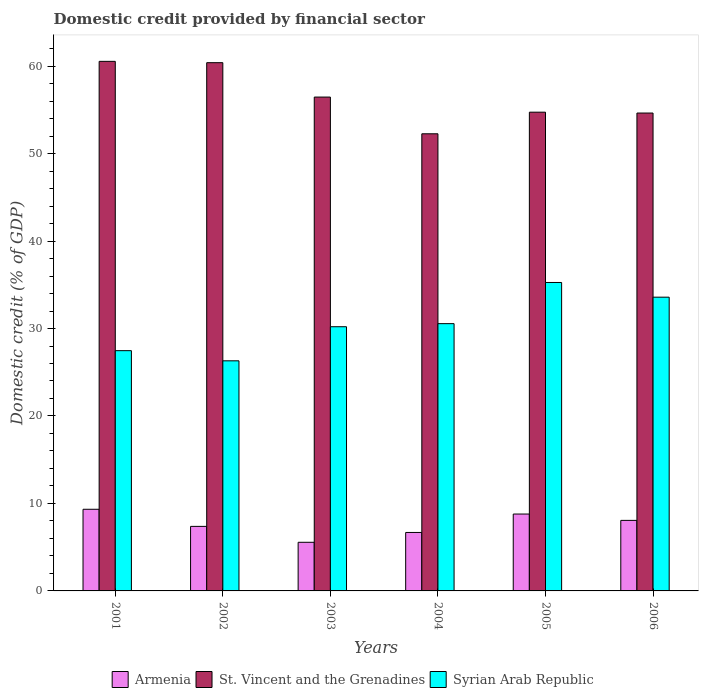Are the number of bars per tick equal to the number of legend labels?
Provide a succinct answer. Yes. How many bars are there on the 6th tick from the right?
Your answer should be very brief. 3. In how many cases, is the number of bars for a given year not equal to the number of legend labels?
Make the answer very short. 0. What is the domestic credit in Syrian Arab Republic in 2003?
Give a very brief answer. 30.2. Across all years, what is the maximum domestic credit in Armenia?
Provide a short and direct response. 9.33. Across all years, what is the minimum domestic credit in St. Vincent and the Grenadines?
Your answer should be compact. 52.26. In which year was the domestic credit in St. Vincent and the Grenadines minimum?
Offer a terse response. 2004. What is the total domestic credit in Syrian Arab Republic in the graph?
Ensure brevity in your answer.  183.38. What is the difference between the domestic credit in Syrian Arab Republic in 2004 and that in 2006?
Your answer should be very brief. -3.03. What is the difference between the domestic credit in Armenia in 2006 and the domestic credit in St. Vincent and the Grenadines in 2004?
Keep it short and to the point. -44.2. What is the average domestic credit in St. Vincent and the Grenadines per year?
Offer a terse response. 56.5. In the year 2003, what is the difference between the domestic credit in St. Vincent and the Grenadines and domestic credit in Armenia?
Give a very brief answer. 50.9. In how many years, is the domestic credit in Armenia greater than 32 %?
Your response must be concise. 0. What is the ratio of the domestic credit in Armenia in 2003 to that in 2005?
Keep it short and to the point. 0.63. Is the domestic credit in St. Vincent and the Grenadines in 2004 less than that in 2005?
Make the answer very short. Yes. Is the difference between the domestic credit in St. Vincent and the Grenadines in 2002 and 2003 greater than the difference between the domestic credit in Armenia in 2002 and 2003?
Your answer should be very brief. Yes. What is the difference between the highest and the second highest domestic credit in Syrian Arab Republic?
Provide a succinct answer. 1.68. What is the difference between the highest and the lowest domestic credit in St. Vincent and the Grenadines?
Make the answer very short. 8.28. What does the 3rd bar from the left in 2003 represents?
Your response must be concise. Syrian Arab Republic. What does the 2nd bar from the right in 2002 represents?
Offer a terse response. St. Vincent and the Grenadines. Are all the bars in the graph horizontal?
Your response must be concise. No. How many years are there in the graph?
Provide a short and direct response. 6. Are the values on the major ticks of Y-axis written in scientific E-notation?
Provide a succinct answer. No. Does the graph contain grids?
Offer a very short reply. No. Where does the legend appear in the graph?
Provide a short and direct response. Bottom center. How are the legend labels stacked?
Your answer should be very brief. Horizontal. What is the title of the graph?
Offer a terse response. Domestic credit provided by financial sector. What is the label or title of the Y-axis?
Offer a very short reply. Domestic credit (% of GDP). What is the Domestic credit (% of GDP) of Armenia in 2001?
Your response must be concise. 9.33. What is the Domestic credit (% of GDP) of St. Vincent and the Grenadines in 2001?
Provide a succinct answer. 60.54. What is the Domestic credit (% of GDP) of Syrian Arab Republic in 2001?
Keep it short and to the point. 27.47. What is the Domestic credit (% of GDP) in Armenia in 2002?
Provide a succinct answer. 7.38. What is the Domestic credit (% of GDP) of St. Vincent and the Grenadines in 2002?
Your answer should be very brief. 60.39. What is the Domestic credit (% of GDP) in Syrian Arab Republic in 2002?
Offer a terse response. 26.31. What is the Domestic credit (% of GDP) of Armenia in 2003?
Offer a very short reply. 5.56. What is the Domestic credit (% of GDP) in St. Vincent and the Grenadines in 2003?
Provide a succinct answer. 56.46. What is the Domestic credit (% of GDP) of Syrian Arab Republic in 2003?
Offer a very short reply. 30.2. What is the Domestic credit (% of GDP) of Armenia in 2004?
Your response must be concise. 6.68. What is the Domestic credit (% of GDP) in St. Vincent and the Grenadines in 2004?
Provide a succinct answer. 52.26. What is the Domestic credit (% of GDP) in Syrian Arab Republic in 2004?
Your answer should be very brief. 30.55. What is the Domestic credit (% of GDP) of Armenia in 2005?
Ensure brevity in your answer.  8.79. What is the Domestic credit (% of GDP) in St. Vincent and the Grenadines in 2005?
Give a very brief answer. 54.73. What is the Domestic credit (% of GDP) of Syrian Arab Republic in 2005?
Ensure brevity in your answer.  35.26. What is the Domestic credit (% of GDP) in Armenia in 2006?
Offer a very short reply. 8.06. What is the Domestic credit (% of GDP) of St. Vincent and the Grenadines in 2006?
Make the answer very short. 54.63. What is the Domestic credit (% of GDP) in Syrian Arab Republic in 2006?
Offer a terse response. 33.58. Across all years, what is the maximum Domestic credit (% of GDP) in Armenia?
Ensure brevity in your answer.  9.33. Across all years, what is the maximum Domestic credit (% of GDP) of St. Vincent and the Grenadines?
Keep it short and to the point. 60.54. Across all years, what is the maximum Domestic credit (% of GDP) in Syrian Arab Republic?
Your answer should be very brief. 35.26. Across all years, what is the minimum Domestic credit (% of GDP) in Armenia?
Your answer should be very brief. 5.56. Across all years, what is the minimum Domestic credit (% of GDP) in St. Vincent and the Grenadines?
Ensure brevity in your answer.  52.26. Across all years, what is the minimum Domestic credit (% of GDP) in Syrian Arab Republic?
Your response must be concise. 26.31. What is the total Domestic credit (% of GDP) in Armenia in the graph?
Give a very brief answer. 45.81. What is the total Domestic credit (% of GDP) in St. Vincent and the Grenadines in the graph?
Your answer should be compact. 339.02. What is the total Domestic credit (% of GDP) of Syrian Arab Republic in the graph?
Your answer should be very brief. 183.38. What is the difference between the Domestic credit (% of GDP) in Armenia in 2001 and that in 2002?
Provide a short and direct response. 1.96. What is the difference between the Domestic credit (% of GDP) of St. Vincent and the Grenadines in 2001 and that in 2002?
Offer a very short reply. 0.15. What is the difference between the Domestic credit (% of GDP) in Syrian Arab Republic in 2001 and that in 2002?
Provide a short and direct response. 1.16. What is the difference between the Domestic credit (% of GDP) of Armenia in 2001 and that in 2003?
Give a very brief answer. 3.78. What is the difference between the Domestic credit (% of GDP) in St. Vincent and the Grenadines in 2001 and that in 2003?
Provide a short and direct response. 4.08. What is the difference between the Domestic credit (% of GDP) of Syrian Arab Republic in 2001 and that in 2003?
Your answer should be compact. -2.74. What is the difference between the Domestic credit (% of GDP) of Armenia in 2001 and that in 2004?
Offer a terse response. 2.65. What is the difference between the Domestic credit (% of GDP) of St. Vincent and the Grenadines in 2001 and that in 2004?
Ensure brevity in your answer.  8.28. What is the difference between the Domestic credit (% of GDP) in Syrian Arab Republic in 2001 and that in 2004?
Keep it short and to the point. -3.09. What is the difference between the Domestic credit (% of GDP) in Armenia in 2001 and that in 2005?
Keep it short and to the point. 0.55. What is the difference between the Domestic credit (% of GDP) in St. Vincent and the Grenadines in 2001 and that in 2005?
Your answer should be compact. 5.81. What is the difference between the Domestic credit (% of GDP) in Syrian Arab Republic in 2001 and that in 2005?
Ensure brevity in your answer.  -7.8. What is the difference between the Domestic credit (% of GDP) of Armenia in 2001 and that in 2006?
Your response must be concise. 1.27. What is the difference between the Domestic credit (% of GDP) of St. Vincent and the Grenadines in 2001 and that in 2006?
Provide a short and direct response. 5.91. What is the difference between the Domestic credit (% of GDP) in Syrian Arab Republic in 2001 and that in 2006?
Your answer should be compact. -6.12. What is the difference between the Domestic credit (% of GDP) of Armenia in 2002 and that in 2003?
Give a very brief answer. 1.82. What is the difference between the Domestic credit (% of GDP) of St. Vincent and the Grenadines in 2002 and that in 2003?
Your answer should be compact. 3.93. What is the difference between the Domestic credit (% of GDP) of Syrian Arab Republic in 2002 and that in 2003?
Your answer should be very brief. -3.9. What is the difference between the Domestic credit (% of GDP) in Armenia in 2002 and that in 2004?
Ensure brevity in your answer.  0.69. What is the difference between the Domestic credit (% of GDP) of St. Vincent and the Grenadines in 2002 and that in 2004?
Your answer should be compact. 8.13. What is the difference between the Domestic credit (% of GDP) of Syrian Arab Republic in 2002 and that in 2004?
Your answer should be very brief. -4.25. What is the difference between the Domestic credit (% of GDP) of Armenia in 2002 and that in 2005?
Give a very brief answer. -1.41. What is the difference between the Domestic credit (% of GDP) in St. Vincent and the Grenadines in 2002 and that in 2005?
Keep it short and to the point. 5.66. What is the difference between the Domestic credit (% of GDP) in Syrian Arab Republic in 2002 and that in 2005?
Give a very brief answer. -8.96. What is the difference between the Domestic credit (% of GDP) in Armenia in 2002 and that in 2006?
Your response must be concise. -0.69. What is the difference between the Domestic credit (% of GDP) in St. Vincent and the Grenadines in 2002 and that in 2006?
Offer a very short reply. 5.76. What is the difference between the Domestic credit (% of GDP) in Syrian Arab Republic in 2002 and that in 2006?
Provide a short and direct response. -7.28. What is the difference between the Domestic credit (% of GDP) of Armenia in 2003 and that in 2004?
Offer a terse response. -1.12. What is the difference between the Domestic credit (% of GDP) in St. Vincent and the Grenadines in 2003 and that in 2004?
Your answer should be very brief. 4.2. What is the difference between the Domestic credit (% of GDP) of Syrian Arab Republic in 2003 and that in 2004?
Keep it short and to the point. -0.35. What is the difference between the Domestic credit (% of GDP) of Armenia in 2003 and that in 2005?
Your response must be concise. -3.23. What is the difference between the Domestic credit (% of GDP) of St. Vincent and the Grenadines in 2003 and that in 2005?
Your answer should be very brief. 1.73. What is the difference between the Domestic credit (% of GDP) of Syrian Arab Republic in 2003 and that in 2005?
Provide a short and direct response. -5.06. What is the difference between the Domestic credit (% of GDP) of Armenia in 2003 and that in 2006?
Your answer should be compact. -2.5. What is the difference between the Domestic credit (% of GDP) in St. Vincent and the Grenadines in 2003 and that in 2006?
Offer a very short reply. 1.83. What is the difference between the Domestic credit (% of GDP) in Syrian Arab Republic in 2003 and that in 2006?
Make the answer very short. -3.38. What is the difference between the Domestic credit (% of GDP) of Armenia in 2004 and that in 2005?
Your answer should be very brief. -2.1. What is the difference between the Domestic credit (% of GDP) in St. Vincent and the Grenadines in 2004 and that in 2005?
Your answer should be compact. -2.47. What is the difference between the Domestic credit (% of GDP) of Syrian Arab Republic in 2004 and that in 2005?
Make the answer very short. -4.71. What is the difference between the Domestic credit (% of GDP) of Armenia in 2004 and that in 2006?
Your answer should be compact. -1.38. What is the difference between the Domestic credit (% of GDP) of St. Vincent and the Grenadines in 2004 and that in 2006?
Your response must be concise. -2.37. What is the difference between the Domestic credit (% of GDP) of Syrian Arab Republic in 2004 and that in 2006?
Provide a short and direct response. -3.03. What is the difference between the Domestic credit (% of GDP) in Armenia in 2005 and that in 2006?
Give a very brief answer. 0.72. What is the difference between the Domestic credit (% of GDP) of St. Vincent and the Grenadines in 2005 and that in 2006?
Your response must be concise. 0.1. What is the difference between the Domestic credit (% of GDP) in Syrian Arab Republic in 2005 and that in 2006?
Offer a very short reply. 1.68. What is the difference between the Domestic credit (% of GDP) in Armenia in 2001 and the Domestic credit (% of GDP) in St. Vincent and the Grenadines in 2002?
Provide a short and direct response. -51.06. What is the difference between the Domestic credit (% of GDP) of Armenia in 2001 and the Domestic credit (% of GDP) of Syrian Arab Republic in 2002?
Keep it short and to the point. -16.97. What is the difference between the Domestic credit (% of GDP) in St. Vincent and the Grenadines in 2001 and the Domestic credit (% of GDP) in Syrian Arab Republic in 2002?
Give a very brief answer. 34.24. What is the difference between the Domestic credit (% of GDP) in Armenia in 2001 and the Domestic credit (% of GDP) in St. Vincent and the Grenadines in 2003?
Your answer should be compact. -47.12. What is the difference between the Domestic credit (% of GDP) of Armenia in 2001 and the Domestic credit (% of GDP) of Syrian Arab Republic in 2003?
Offer a terse response. -20.87. What is the difference between the Domestic credit (% of GDP) of St. Vincent and the Grenadines in 2001 and the Domestic credit (% of GDP) of Syrian Arab Republic in 2003?
Your answer should be compact. 30.34. What is the difference between the Domestic credit (% of GDP) of Armenia in 2001 and the Domestic credit (% of GDP) of St. Vincent and the Grenadines in 2004?
Ensure brevity in your answer.  -42.93. What is the difference between the Domestic credit (% of GDP) in Armenia in 2001 and the Domestic credit (% of GDP) in Syrian Arab Republic in 2004?
Provide a short and direct response. -21.22. What is the difference between the Domestic credit (% of GDP) of St. Vincent and the Grenadines in 2001 and the Domestic credit (% of GDP) of Syrian Arab Republic in 2004?
Provide a succinct answer. 29.99. What is the difference between the Domestic credit (% of GDP) in Armenia in 2001 and the Domestic credit (% of GDP) in St. Vincent and the Grenadines in 2005?
Keep it short and to the point. -45.4. What is the difference between the Domestic credit (% of GDP) of Armenia in 2001 and the Domestic credit (% of GDP) of Syrian Arab Republic in 2005?
Give a very brief answer. -25.93. What is the difference between the Domestic credit (% of GDP) in St. Vincent and the Grenadines in 2001 and the Domestic credit (% of GDP) in Syrian Arab Republic in 2005?
Provide a short and direct response. 25.28. What is the difference between the Domestic credit (% of GDP) of Armenia in 2001 and the Domestic credit (% of GDP) of St. Vincent and the Grenadines in 2006?
Your answer should be compact. -45.3. What is the difference between the Domestic credit (% of GDP) of Armenia in 2001 and the Domestic credit (% of GDP) of Syrian Arab Republic in 2006?
Provide a succinct answer. -24.25. What is the difference between the Domestic credit (% of GDP) in St. Vincent and the Grenadines in 2001 and the Domestic credit (% of GDP) in Syrian Arab Republic in 2006?
Ensure brevity in your answer.  26.96. What is the difference between the Domestic credit (% of GDP) of Armenia in 2002 and the Domestic credit (% of GDP) of St. Vincent and the Grenadines in 2003?
Your response must be concise. -49.08. What is the difference between the Domestic credit (% of GDP) in Armenia in 2002 and the Domestic credit (% of GDP) in Syrian Arab Republic in 2003?
Make the answer very short. -22.82. What is the difference between the Domestic credit (% of GDP) in St. Vincent and the Grenadines in 2002 and the Domestic credit (% of GDP) in Syrian Arab Republic in 2003?
Your answer should be very brief. 30.19. What is the difference between the Domestic credit (% of GDP) in Armenia in 2002 and the Domestic credit (% of GDP) in St. Vincent and the Grenadines in 2004?
Your response must be concise. -44.88. What is the difference between the Domestic credit (% of GDP) in Armenia in 2002 and the Domestic credit (% of GDP) in Syrian Arab Republic in 2004?
Your response must be concise. -23.18. What is the difference between the Domestic credit (% of GDP) in St. Vincent and the Grenadines in 2002 and the Domestic credit (% of GDP) in Syrian Arab Republic in 2004?
Offer a terse response. 29.84. What is the difference between the Domestic credit (% of GDP) of Armenia in 2002 and the Domestic credit (% of GDP) of St. Vincent and the Grenadines in 2005?
Make the answer very short. -47.35. What is the difference between the Domestic credit (% of GDP) of Armenia in 2002 and the Domestic credit (% of GDP) of Syrian Arab Republic in 2005?
Keep it short and to the point. -27.88. What is the difference between the Domestic credit (% of GDP) in St. Vincent and the Grenadines in 2002 and the Domestic credit (% of GDP) in Syrian Arab Republic in 2005?
Provide a succinct answer. 25.13. What is the difference between the Domestic credit (% of GDP) in Armenia in 2002 and the Domestic credit (% of GDP) in St. Vincent and the Grenadines in 2006?
Give a very brief answer. -47.25. What is the difference between the Domestic credit (% of GDP) of Armenia in 2002 and the Domestic credit (% of GDP) of Syrian Arab Republic in 2006?
Your answer should be compact. -26.2. What is the difference between the Domestic credit (% of GDP) in St. Vincent and the Grenadines in 2002 and the Domestic credit (% of GDP) in Syrian Arab Republic in 2006?
Your answer should be compact. 26.81. What is the difference between the Domestic credit (% of GDP) in Armenia in 2003 and the Domestic credit (% of GDP) in St. Vincent and the Grenadines in 2004?
Offer a terse response. -46.7. What is the difference between the Domestic credit (% of GDP) of Armenia in 2003 and the Domestic credit (% of GDP) of Syrian Arab Republic in 2004?
Offer a very short reply. -25. What is the difference between the Domestic credit (% of GDP) in St. Vincent and the Grenadines in 2003 and the Domestic credit (% of GDP) in Syrian Arab Republic in 2004?
Provide a succinct answer. 25.9. What is the difference between the Domestic credit (% of GDP) in Armenia in 2003 and the Domestic credit (% of GDP) in St. Vincent and the Grenadines in 2005?
Ensure brevity in your answer.  -49.17. What is the difference between the Domestic credit (% of GDP) of Armenia in 2003 and the Domestic credit (% of GDP) of Syrian Arab Republic in 2005?
Offer a very short reply. -29.7. What is the difference between the Domestic credit (% of GDP) of St. Vincent and the Grenadines in 2003 and the Domestic credit (% of GDP) of Syrian Arab Republic in 2005?
Ensure brevity in your answer.  21.2. What is the difference between the Domestic credit (% of GDP) in Armenia in 2003 and the Domestic credit (% of GDP) in St. Vincent and the Grenadines in 2006?
Ensure brevity in your answer.  -49.07. What is the difference between the Domestic credit (% of GDP) of Armenia in 2003 and the Domestic credit (% of GDP) of Syrian Arab Republic in 2006?
Your answer should be very brief. -28.02. What is the difference between the Domestic credit (% of GDP) in St. Vincent and the Grenadines in 2003 and the Domestic credit (% of GDP) in Syrian Arab Republic in 2006?
Offer a terse response. 22.88. What is the difference between the Domestic credit (% of GDP) of Armenia in 2004 and the Domestic credit (% of GDP) of St. Vincent and the Grenadines in 2005?
Ensure brevity in your answer.  -48.05. What is the difference between the Domestic credit (% of GDP) in Armenia in 2004 and the Domestic credit (% of GDP) in Syrian Arab Republic in 2005?
Offer a very short reply. -28.58. What is the difference between the Domestic credit (% of GDP) in St. Vincent and the Grenadines in 2004 and the Domestic credit (% of GDP) in Syrian Arab Republic in 2005?
Keep it short and to the point. 17. What is the difference between the Domestic credit (% of GDP) in Armenia in 2004 and the Domestic credit (% of GDP) in St. Vincent and the Grenadines in 2006?
Your answer should be compact. -47.95. What is the difference between the Domestic credit (% of GDP) of Armenia in 2004 and the Domestic credit (% of GDP) of Syrian Arab Republic in 2006?
Offer a terse response. -26.9. What is the difference between the Domestic credit (% of GDP) of St. Vincent and the Grenadines in 2004 and the Domestic credit (% of GDP) of Syrian Arab Republic in 2006?
Your response must be concise. 18.68. What is the difference between the Domestic credit (% of GDP) of Armenia in 2005 and the Domestic credit (% of GDP) of St. Vincent and the Grenadines in 2006?
Offer a terse response. -45.84. What is the difference between the Domestic credit (% of GDP) in Armenia in 2005 and the Domestic credit (% of GDP) in Syrian Arab Republic in 2006?
Offer a terse response. -24.79. What is the difference between the Domestic credit (% of GDP) in St. Vincent and the Grenadines in 2005 and the Domestic credit (% of GDP) in Syrian Arab Republic in 2006?
Your answer should be compact. 21.15. What is the average Domestic credit (% of GDP) of Armenia per year?
Give a very brief answer. 7.63. What is the average Domestic credit (% of GDP) of St. Vincent and the Grenadines per year?
Provide a succinct answer. 56.5. What is the average Domestic credit (% of GDP) in Syrian Arab Republic per year?
Keep it short and to the point. 30.56. In the year 2001, what is the difference between the Domestic credit (% of GDP) in Armenia and Domestic credit (% of GDP) in St. Vincent and the Grenadines?
Give a very brief answer. -51.21. In the year 2001, what is the difference between the Domestic credit (% of GDP) in Armenia and Domestic credit (% of GDP) in Syrian Arab Republic?
Offer a terse response. -18.13. In the year 2001, what is the difference between the Domestic credit (% of GDP) in St. Vincent and the Grenadines and Domestic credit (% of GDP) in Syrian Arab Republic?
Provide a short and direct response. 33.08. In the year 2002, what is the difference between the Domestic credit (% of GDP) in Armenia and Domestic credit (% of GDP) in St. Vincent and the Grenadines?
Ensure brevity in your answer.  -53.01. In the year 2002, what is the difference between the Domestic credit (% of GDP) in Armenia and Domestic credit (% of GDP) in Syrian Arab Republic?
Offer a terse response. -18.93. In the year 2002, what is the difference between the Domestic credit (% of GDP) in St. Vincent and the Grenadines and Domestic credit (% of GDP) in Syrian Arab Republic?
Your answer should be compact. 34.08. In the year 2003, what is the difference between the Domestic credit (% of GDP) in Armenia and Domestic credit (% of GDP) in St. Vincent and the Grenadines?
Provide a short and direct response. -50.9. In the year 2003, what is the difference between the Domestic credit (% of GDP) in Armenia and Domestic credit (% of GDP) in Syrian Arab Republic?
Give a very brief answer. -24.64. In the year 2003, what is the difference between the Domestic credit (% of GDP) in St. Vincent and the Grenadines and Domestic credit (% of GDP) in Syrian Arab Republic?
Offer a very short reply. 26.26. In the year 2004, what is the difference between the Domestic credit (% of GDP) in Armenia and Domestic credit (% of GDP) in St. Vincent and the Grenadines?
Provide a succinct answer. -45.58. In the year 2004, what is the difference between the Domestic credit (% of GDP) of Armenia and Domestic credit (% of GDP) of Syrian Arab Republic?
Ensure brevity in your answer.  -23.87. In the year 2004, what is the difference between the Domestic credit (% of GDP) of St. Vincent and the Grenadines and Domestic credit (% of GDP) of Syrian Arab Republic?
Your answer should be compact. 21.71. In the year 2005, what is the difference between the Domestic credit (% of GDP) in Armenia and Domestic credit (% of GDP) in St. Vincent and the Grenadines?
Keep it short and to the point. -45.94. In the year 2005, what is the difference between the Domestic credit (% of GDP) of Armenia and Domestic credit (% of GDP) of Syrian Arab Republic?
Make the answer very short. -26.47. In the year 2005, what is the difference between the Domestic credit (% of GDP) in St. Vincent and the Grenadines and Domestic credit (% of GDP) in Syrian Arab Republic?
Offer a very short reply. 19.47. In the year 2006, what is the difference between the Domestic credit (% of GDP) in Armenia and Domestic credit (% of GDP) in St. Vincent and the Grenadines?
Provide a short and direct response. -46.57. In the year 2006, what is the difference between the Domestic credit (% of GDP) of Armenia and Domestic credit (% of GDP) of Syrian Arab Republic?
Offer a very short reply. -25.52. In the year 2006, what is the difference between the Domestic credit (% of GDP) of St. Vincent and the Grenadines and Domestic credit (% of GDP) of Syrian Arab Republic?
Your answer should be compact. 21.05. What is the ratio of the Domestic credit (% of GDP) of Armenia in 2001 to that in 2002?
Make the answer very short. 1.27. What is the ratio of the Domestic credit (% of GDP) of Syrian Arab Republic in 2001 to that in 2002?
Your answer should be very brief. 1.04. What is the ratio of the Domestic credit (% of GDP) of Armenia in 2001 to that in 2003?
Make the answer very short. 1.68. What is the ratio of the Domestic credit (% of GDP) of St. Vincent and the Grenadines in 2001 to that in 2003?
Keep it short and to the point. 1.07. What is the ratio of the Domestic credit (% of GDP) in Syrian Arab Republic in 2001 to that in 2003?
Offer a very short reply. 0.91. What is the ratio of the Domestic credit (% of GDP) in Armenia in 2001 to that in 2004?
Keep it short and to the point. 1.4. What is the ratio of the Domestic credit (% of GDP) of St. Vincent and the Grenadines in 2001 to that in 2004?
Provide a succinct answer. 1.16. What is the ratio of the Domestic credit (% of GDP) of Syrian Arab Republic in 2001 to that in 2004?
Make the answer very short. 0.9. What is the ratio of the Domestic credit (% of GDP) of Armenia in 2001 to that in 2005?
Your answer should be compact. 1.06. What is the ratio of the Domestic credit (% of GDP) of St. Vincent and the Grenadines in 2001 to that in 2005?
Your response must be concise. 1.11. What is the ratio of the Domestic credit (% of GDP) of Syrian Arab Republic in 2001 to that in 2005?
Offer a very short reply. 0.78. What is the ratio of the Domestic credit (% of GDP) of Armenia in 2001 to that in 2006?
Offer a terse response. 1.16. What is the ratio of the Domestic credit (% of GDP) of St. Vincent and the Grenadines in 2001 to that in 2006?
Provide a short and direct response. 1.11. What is the ratio of the Domestic credit (% of GDP) in Syrian Arab Republic in 2001 to that in 2006?
Offer a terse response. 0.82. What is the ratio of the Domestic credit (% of GDP) of Armenia in 2002 to that in 2003?
Ensure brevity in your answer.  1.33. What is the ratio of the Domestic credit (% of GDP) in St. Vincent and the Grenadines in 2002 to that in 2003?
Your response must be concise. 1.07. What is the ratio of the Domestic credit (% of GDP) in Syrian Arab Republic in 2002 to that in 2003?
Give a very brief answer. 0.87. What is the ratio of the Domestic credit (% of GDP) in Armenia in 2002 to that in 2004?
Offer a very short reply. 1.1. What is the ratio of the Domestic credit (% of GDP) of St. Vincent and the Grenadines in 2002 to that in 2004?
Give a very brief answer. 1.16. What is the ratio of the Domestic credit (% of GDP) in Syrian Arab Republic in 2002 to that in 2004?
Ensure brevity in your answer.  0.86. What is the ratio of the Domestic credit (% of GDP) of Armenia in 2002 to that in 2005?
Make the answer very short. 0.84. What is the ratio of the Domestic credit (% of GDP) of St. Vincent and the Grenadines in 2002 to that in 2005?
Keep it short and to the point. 1.1. What is the ratio of the Domestic credit (% of GDP) of Syrian Arab Republic in 2002 to that in 2005?
Your response must be concise. 0.75. What is the ratio of the Domestic credit (% of GDP) of Armenia in 2002 to that in 2006?
Give a very brief answer. 0.91. What is the ratio of the Domestic credit (% of GDP) of St. Vincent and the Grenadines in 2002 to that in 2006?
Offer a terse response. 1.11. What is the ratio of the Domestic credit (% of GDP) in Syrian Arab Republic in 2002 to that in 2006?
Provide a succinct answer. 0.78. What is the ratio of the Domestic credit (% of GDP) in Armenia in 2003 to that in 2004?
Ensure brevity in your answer.  0.83. What is the ratio of the Domestic credit (% of GDP) of St. Vincent and the Grenadines in 2003 to that in 2004?
Provide a succinct answer. 1.08. What is the ratio of the Domestic credit (% of GDP) in Armenia in 2003 to that in 2005?
Provide a succinct answer. 0.63. What is the ratio of the Domestic credit (% of GDP) in St. Vincent and the Grenadines in 2003 to that in 2005?
Offer a terse response. 1.03. What is the ratio of the Domestic credit (% of GDP) of Syrian Arab Republic in 2003 to that in 2005?
Your answer should be compact. 0.86. What is the ratio of the Domestic credit (% of GDP) of Armenia in 2003 to that in 2006?
Offer a terse response. 0.69. What is the ratio of the Domestic credit (% of GDP) of St. Vincent and the Grenadines in 2003 to that in 2006?
Ensure brevity in your answer.  1.03. What is the ratio of the Domestic credit (% of GDP) in Syrian Arab Republic in 2003 to that in 2006?
Ensure brevity in your answer.  0.9. What is the ratio of the Domestic credit (% of GDP) in Armenia in 2004 to that in 2005?
Your answer should be compact. 0.76. What is the ratio of the Domestic credit (% of GDP) of St. Vincent and the Grenadines in 2004 to that in 2005?
Keep it short and to the point. 0.95. What is the ratio of the Domestic credit (% of GDP) in Syrian Arab Republic in 2004 to that in 2005?
Your response must be concise. 0.87. What is the ratio of the Domestic credit (% of GDP) in Armenia in 2004 to that in 2006?
Make the answer very short. 0.83. What is the ratio of the Domestic credit (% of GDP) of St. Vincent and the Grenadines in 2004 to that in 2006?
Make the answer very short. 0.96. What is the ratio of the Domestic credit (% of GDP) in Syrian Arab Republic in 2004 to that in 2006?
Make the answer very short. 0.91. What is the ratio of the Domestic credit (% of GDP) in Armenia in 2005 to that in 2006?
Offer a terse response. 1.09. What is the ratio of the Domestic credit (% of GDP) of St. Vincent and the Grenadines in 2005 to that in 2006?
Give a very brief answer. 1. What is the difference between the highest and the second highest Domestic credit (% of GDP) of Armenia?
Make the answer very short. 0.55. What is the difference between the highest and the second highest Domestic credit (% of GDP) of St. Vincent and the Grenadines?
Your answer should be compact. 0.15. What is the difference between the highest and the second highest Domestic credit (% of GDP) in Syrian Arab Republic?
Make the answer very short. 1.68. What is the difference between the highest and the lowest Domestic credit (% of GDP) in Armenia?
Give a very brief answer. 3.78. What is the difference between the highest and the lowest Domestic credit (% of GDP) of St. Vincent and the Grenadines?
Provide a short and direct response. 8.28. What is the difference between the highest and the lowest Domestic credit (% of GDP) of Syrian Arab Republic?
Ensure brevity in your answer.  8.96. 